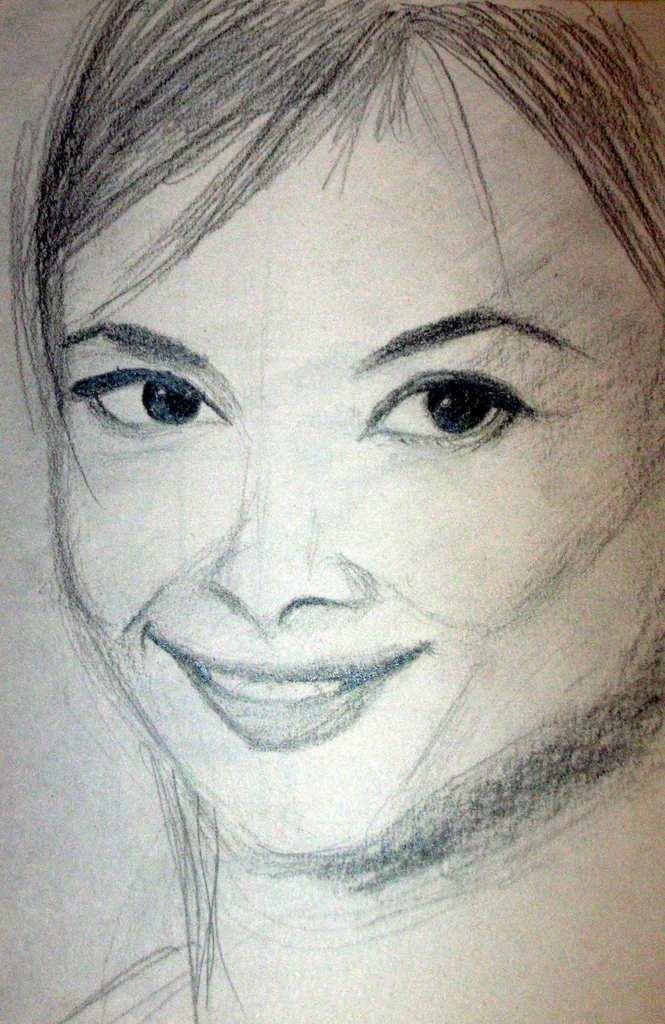Could you give a brief overview of what you see in this image? In this image we can see a pencil sketch of a woman. 